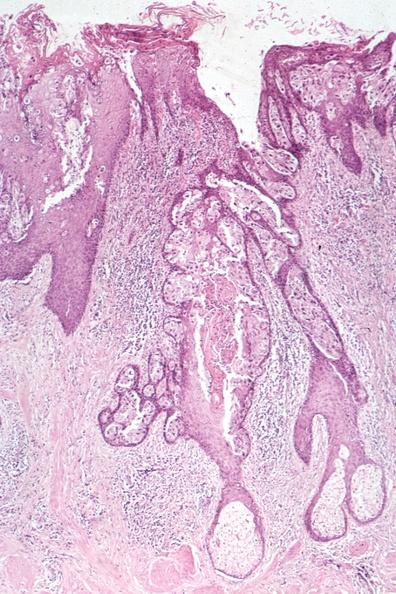how is this image a quite example of pagets disease?
Answer the question using a single word or phrase. Good 